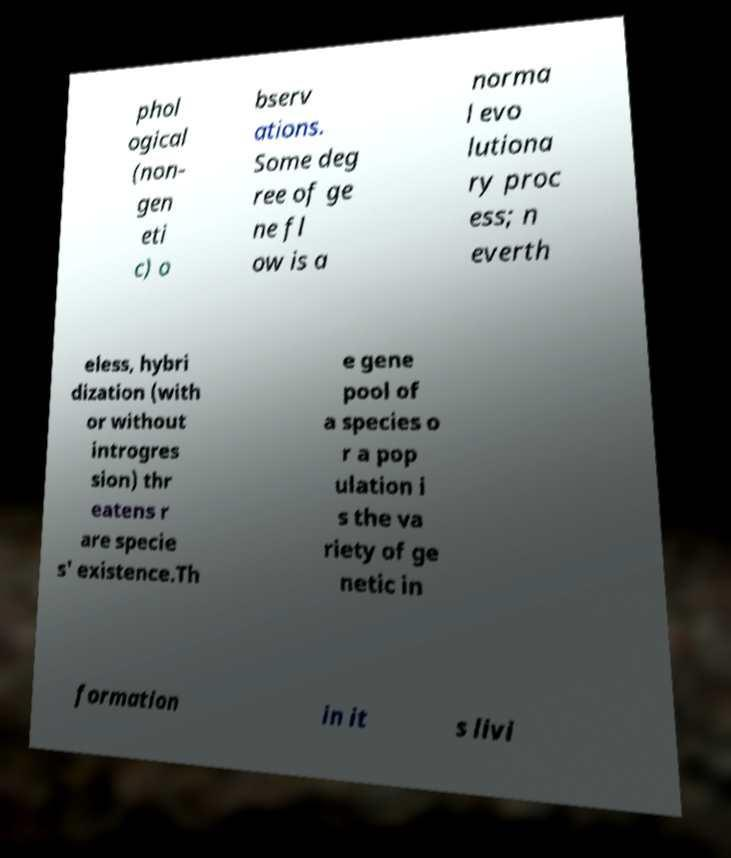Can you read and provide the text displayed in the image?This photo seems to have some interesting text. Can you extract and type it out for me? phol ogical (non- gen eti c) o bserv ations. Some deg ree of ge ne fl ow is a norma l evo lutiona ry proc ess; n everth eless, hybri dization (with or without introgres sion) thr eatens r are specie s' existence.Th e gene pool of a species o r a pop ulation i s the va riety of ge netic in formation in it s livi 